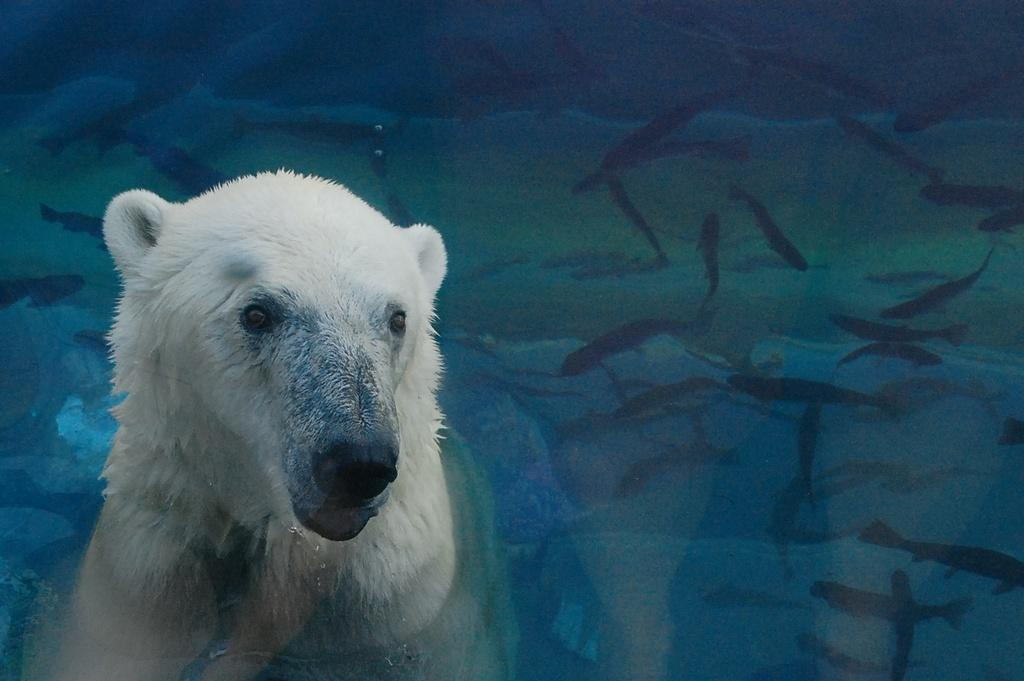What type of animal is in the image? There is an animal in the image, but the specific type cannot be determined from the provided facts. What else is present in the image besides the animal? There are fishes in the image. Where are the fishes located? The fishes are in the water. What type of window can be seen in the image? There is no window present in the image; it features an animal and fishes in the water. How many cabbages are visible in the image? There is no cabbage present in the image. 